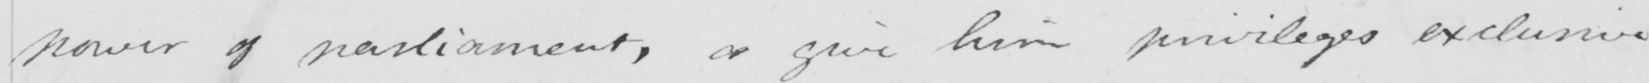What is written in this line of handwriting? power of parliament , or give him privileges exclusive 